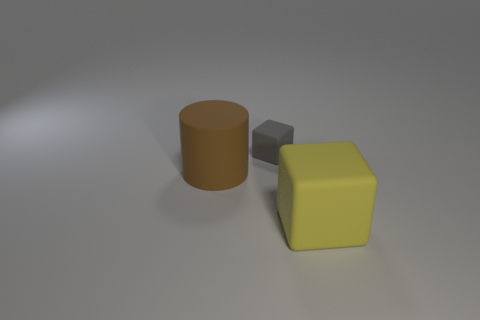Is there any other thing that has the same size as the gray block?
Your response must be concise. No. How many yellow things have the same shape as the gray rubber thing?
Offer a terse response. 1. There is a cylinder that is the same material as the big yellow object; what is its size?
Provide a succinct answer. Large. How many gray rubber blocks have the same size as the brown rubber object?
Give a very brief answer. 0. There is a big thing that is on the right side of the block that is left of the yellow cube; what color is it?
Provide a short and direct response. Yellow. Are there any rubber cubes of the same color as the large cylinder?
Ensure brevity in your answer.  No. The rubber cylinder that is the same size as the yellow matte cube is what color?
Make the answer very short. Brown. There is a rubber block behind the large rubber object to the left of the small thing; are there any large brown matte cylinders on the left side of it?
Provide a succinct answer. Yes. There is a big rubber object in front of the cylinder; does it have the same shape as the tiny rubber thing?
Your answer should be compact. Yes. The thing that is to the right of the cube that is to the left of the big matte block is what shape?
Offer a terse response. Cube. 